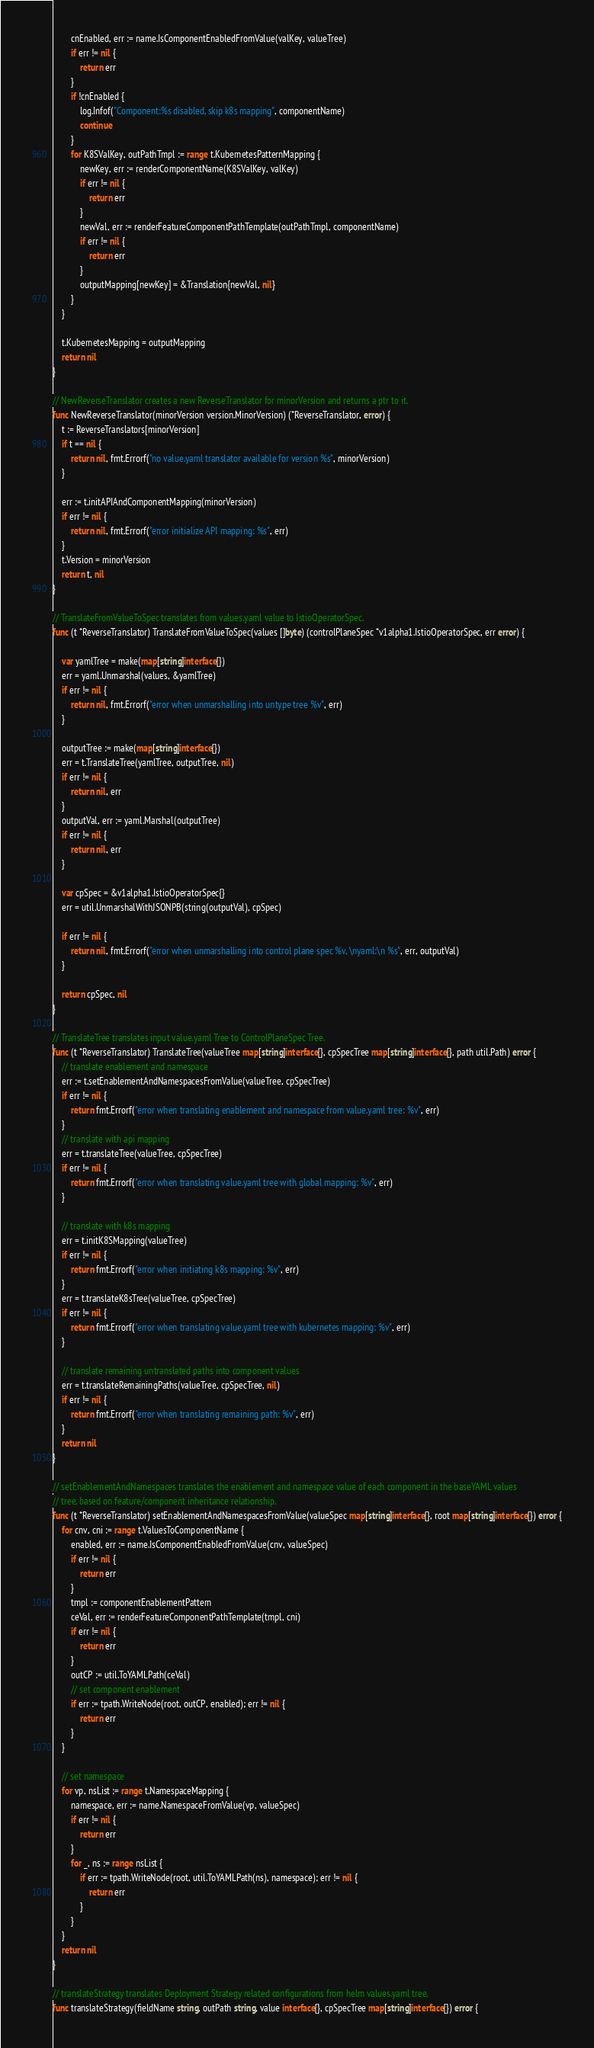Convert code to text. <code><loc_0><loc_0><loc_500><loc_500><_Go_>		cnEnabled, err := name.IsComponentEnabledFromValue(valKey, valueTree)
		if err != nil {
			return err
		}
		if !cnEnabled {
			log.Infof("Component:%s disabled, skip k8s mapping", componentName)
			continue
		}
		for K8SValKey, outPathTmpl := range t.KubernetesPatternMapping {
			newKey, err := renderComponentName(K8SValKey, valKey)
			if err != nil {
				return err
			}
			newVal, err := renderFeatureComponentPathTemplate(outPathTmpl, componentName)
			if err != nil {
				return err
			}
			outputMapping[newKey] = &Translation{newVal, nil}
		}
	}

	t.KubernetesMapping = outputMapping
	return nil
}

// NewReverseTranslator creates a new ReverseTranslator for minorVersion and returns a ptr to it.
func NewReverseTranslator(minorVersion version.MinorVersion) (*ReverseTranslator, error) {
	t := ReverseTranslators[minorVersion]
	if t == nil {
		return nil, fmt.Errorf("no value.yaml translator available for version %s", minorVersion)
	}

	err := t.initAPIAndComponentMapping(minorVersion)
	if err != nil {
		return nil, fmt.Errorf("error initialize API mapping: %s", err)
	}
	t.Version = minorVersion
	return t, nil
}

// TranslateFromValueToSpec translates from values.yaml value to IstioOperatorSpec.
func (t *ReverseTranslator) TranslateFromValueToSpec(values []byte) (controlPlaneSpec *v1alpha1.IstioOperatorSpec, err error) {

	var yamlTree = make(map[string]interface{})
	err = yaml.Unmarshal(values, &yamlTree)
	if err != nil {
		return nil, fmt.Errorf("error when unmarshalling into untype tree %v", err)
	}

	outputTree := make(map[string]interface{})
	err = t.TranslateTree(yamlTree, outputTree, nil)
	if err != nil {
		return nil, err
	}
	outputVal, err := yaml.Marshal(outputTree)
	if err != nil {
		return nil, err
	}

	var cpSpec = &v1alpha1.IstioOperatorSpec{}
	err = util.UnmarshalWithJSONPB(string(outputVal), cpSpec)

	if err != nil {
		return nil, fmt.Errorf("error when unmarshalling into control plane spec %v, \nyaml:\n %s", err, outputVal)
	}

	return cpSpec, nil
}

// TranslateTree translates input value.yaml Tree to ControlPlaneSpec Tree.
func (t *ReverseTranslator) TranslateTree(valueTree map[string]interface{}, cpSpecTree map[string]interface{}, path util.Path) error {
	// translate enablement and namespace
	err := t.setEnablementAndNamespacesFromValue(valueTree, cpSpecTree)
	if err != nil {
		return fmt.Errorf("error when translating enablement and namespace from value.yaml tree: %v", err)
	}
	// translate with api mapping
	err = t.translateTree(valueTree, cpSpecTree)
	if err != nil {
		return fmt.Errorf("error when translating value.yaml tree with global mapping: %v", err)
	}

	// translate with k8s mapping
	err = t.initK8SMapping(valueTree)
	if err != nil {
		return fmt.Errorf("error when initiating k8s mapping: %v", err)
	}
	err = t.translateK8sTree(valueTree, cpSpecTree)
	if err != nil {
		return fmt.Errorf("error when translating value.yaml tree with kubernetes mapping: %v", err)
	}

	// translate remaining untranslated paths into component values
	err = t.translateRemainingPaths(valueTree, cpSpecTree, nil)
	if err != nil {
		return fmt.Errorf("error when translating remaining path: %v", err)
	}
	return nil
}

// setEnablementAndNamespaces translates the enablement and namespace value of each component in the baseYAML values
// tree, based on feature/component inheritance relationship.
func (t *ReverseTranslator) setEnablementAndNamespacesFromValue(valueSpec map[string]interface{}, root map[string]interface{}) error {
	for cnv, cni := range t.ValuesToComponentName {
		enabled, err := name.IsComponentEnabledFromValue(cnv, valueSpec)
		if err != nil {
			return err
		}
		tmpl := componentEnablementPattern
		ceVal, err := renderFeatureComponentPathTemplate(tmpl, cni)
		if err != nil {
			return err
		}
		outCP := util.ToYAMLPath(ceVal)
		// set component enablement
		if err := tpath.WriteNode(root, outCP, enabled); err != nil {
			return err
		}
	}

	// set namespace
	for vp, nsList := range t.NamespaceMapping {
		namespace, err := name.NamespaceFromValue(vp, valueSpec)
		if err != nil {
			return err
		}
		for _, ns := range nsList {
			if err := tpath.WriteNode(root, util.ToYAMLPath(ns), namespace); err != nil {
				return err
			}
		}
	}
	return nil
}

// translateStrategy translates Deployment Strategy related configurations from helm values.yaml tree.
func translateStrategy(fieldName string, outPath string, value interface{}, cpSpecTree map[string]interface{}) error {</code> 